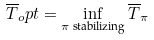<formula> <loc_0><loc_0><loc_500><loc_500>\overline { T } _ { o } p t = \inf _ { \pi \text { stabilizing} } \overline { T } _ { \pi }</formula> 